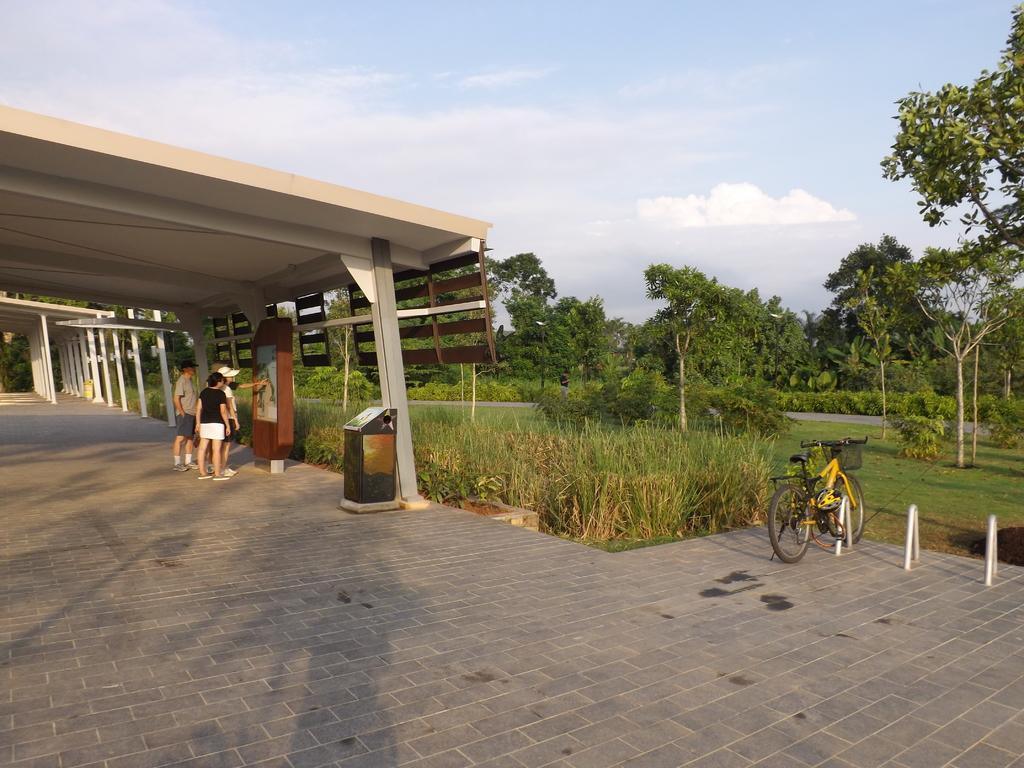In one or two sentences, can you explain what this image depicts? On the left side there is a ceiling, beneath the ceiling there are a few people standing. On the right side of the image there are trees and bicycle. In the background there is a sky. 